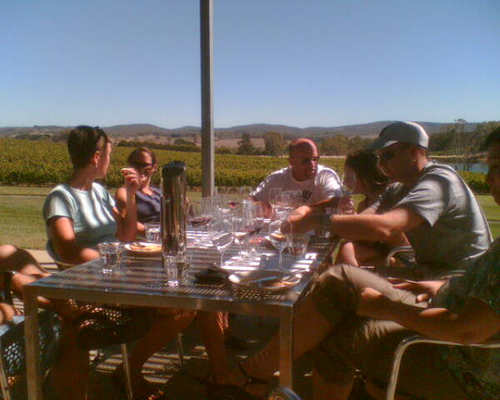<image>Is this a family having a party? I can't determine if this is a family having a party. It could be both yes or no. Is this a family having a party? I am not sure if this is a family having a party. It can be both a family having a party or not. 